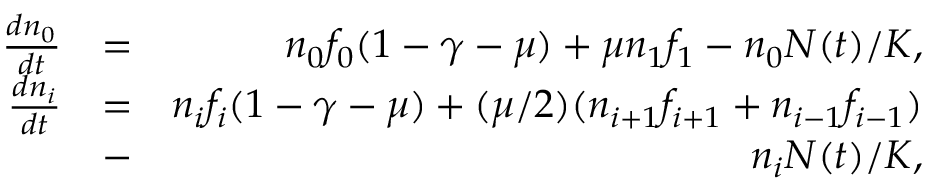Convert formula to latex. <formula><loc_0><loc_0><loc_500><loc_500>\begin{array} { r l r } { \frac { d n _ { 0 } } { d t } } & { = } & { n _ { 0 } f _ { 0 } ( 1 - \gamma - \mu ) + \mu n _ { 1 } f _ { 1 } - n _ { 0 } N ( t ) / K , } \\ { \frac { d n _ { i } } { d t } } & { = } & { n _ { i } f _ { i } ( 1 - \gamma - \mu ) + ( \mu / 2 ) ( n _ { i + 1 } f _ { i + 1 } + n _ { i - 1 } f _ { i - 1 } ) } \\ & { - } & { n _ { i } N ( t ) / K , } \end{array}</formula> 